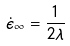<formula> <loc_0><loc_0><loc_500><loc_500>\dot { \epsilon } _ { \infty } = \frac { 1 } { 2 \lambda }</formula> 